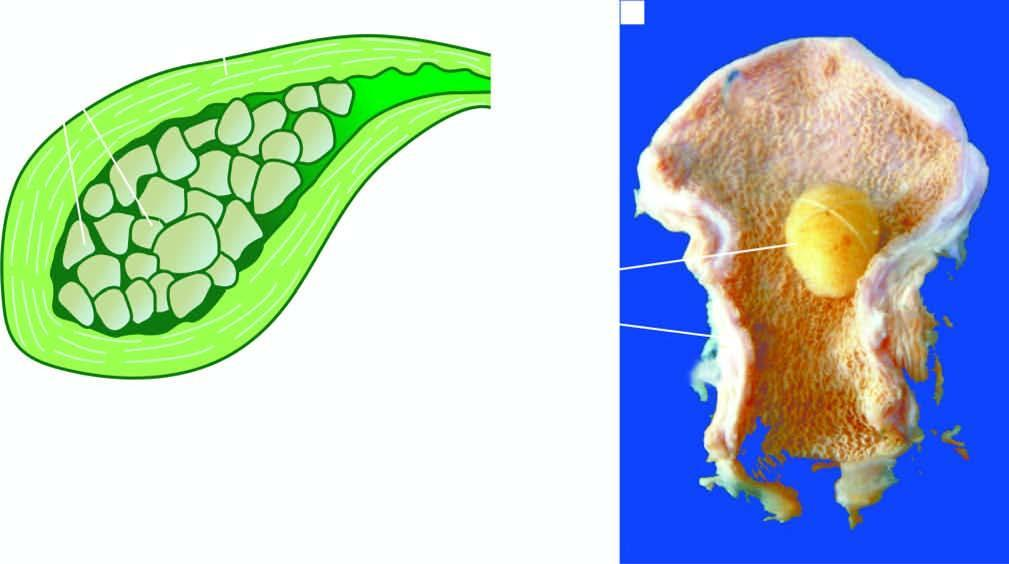s the wall of the gallbladder thickened?
Answer the question using a single word or phrase. Yes 